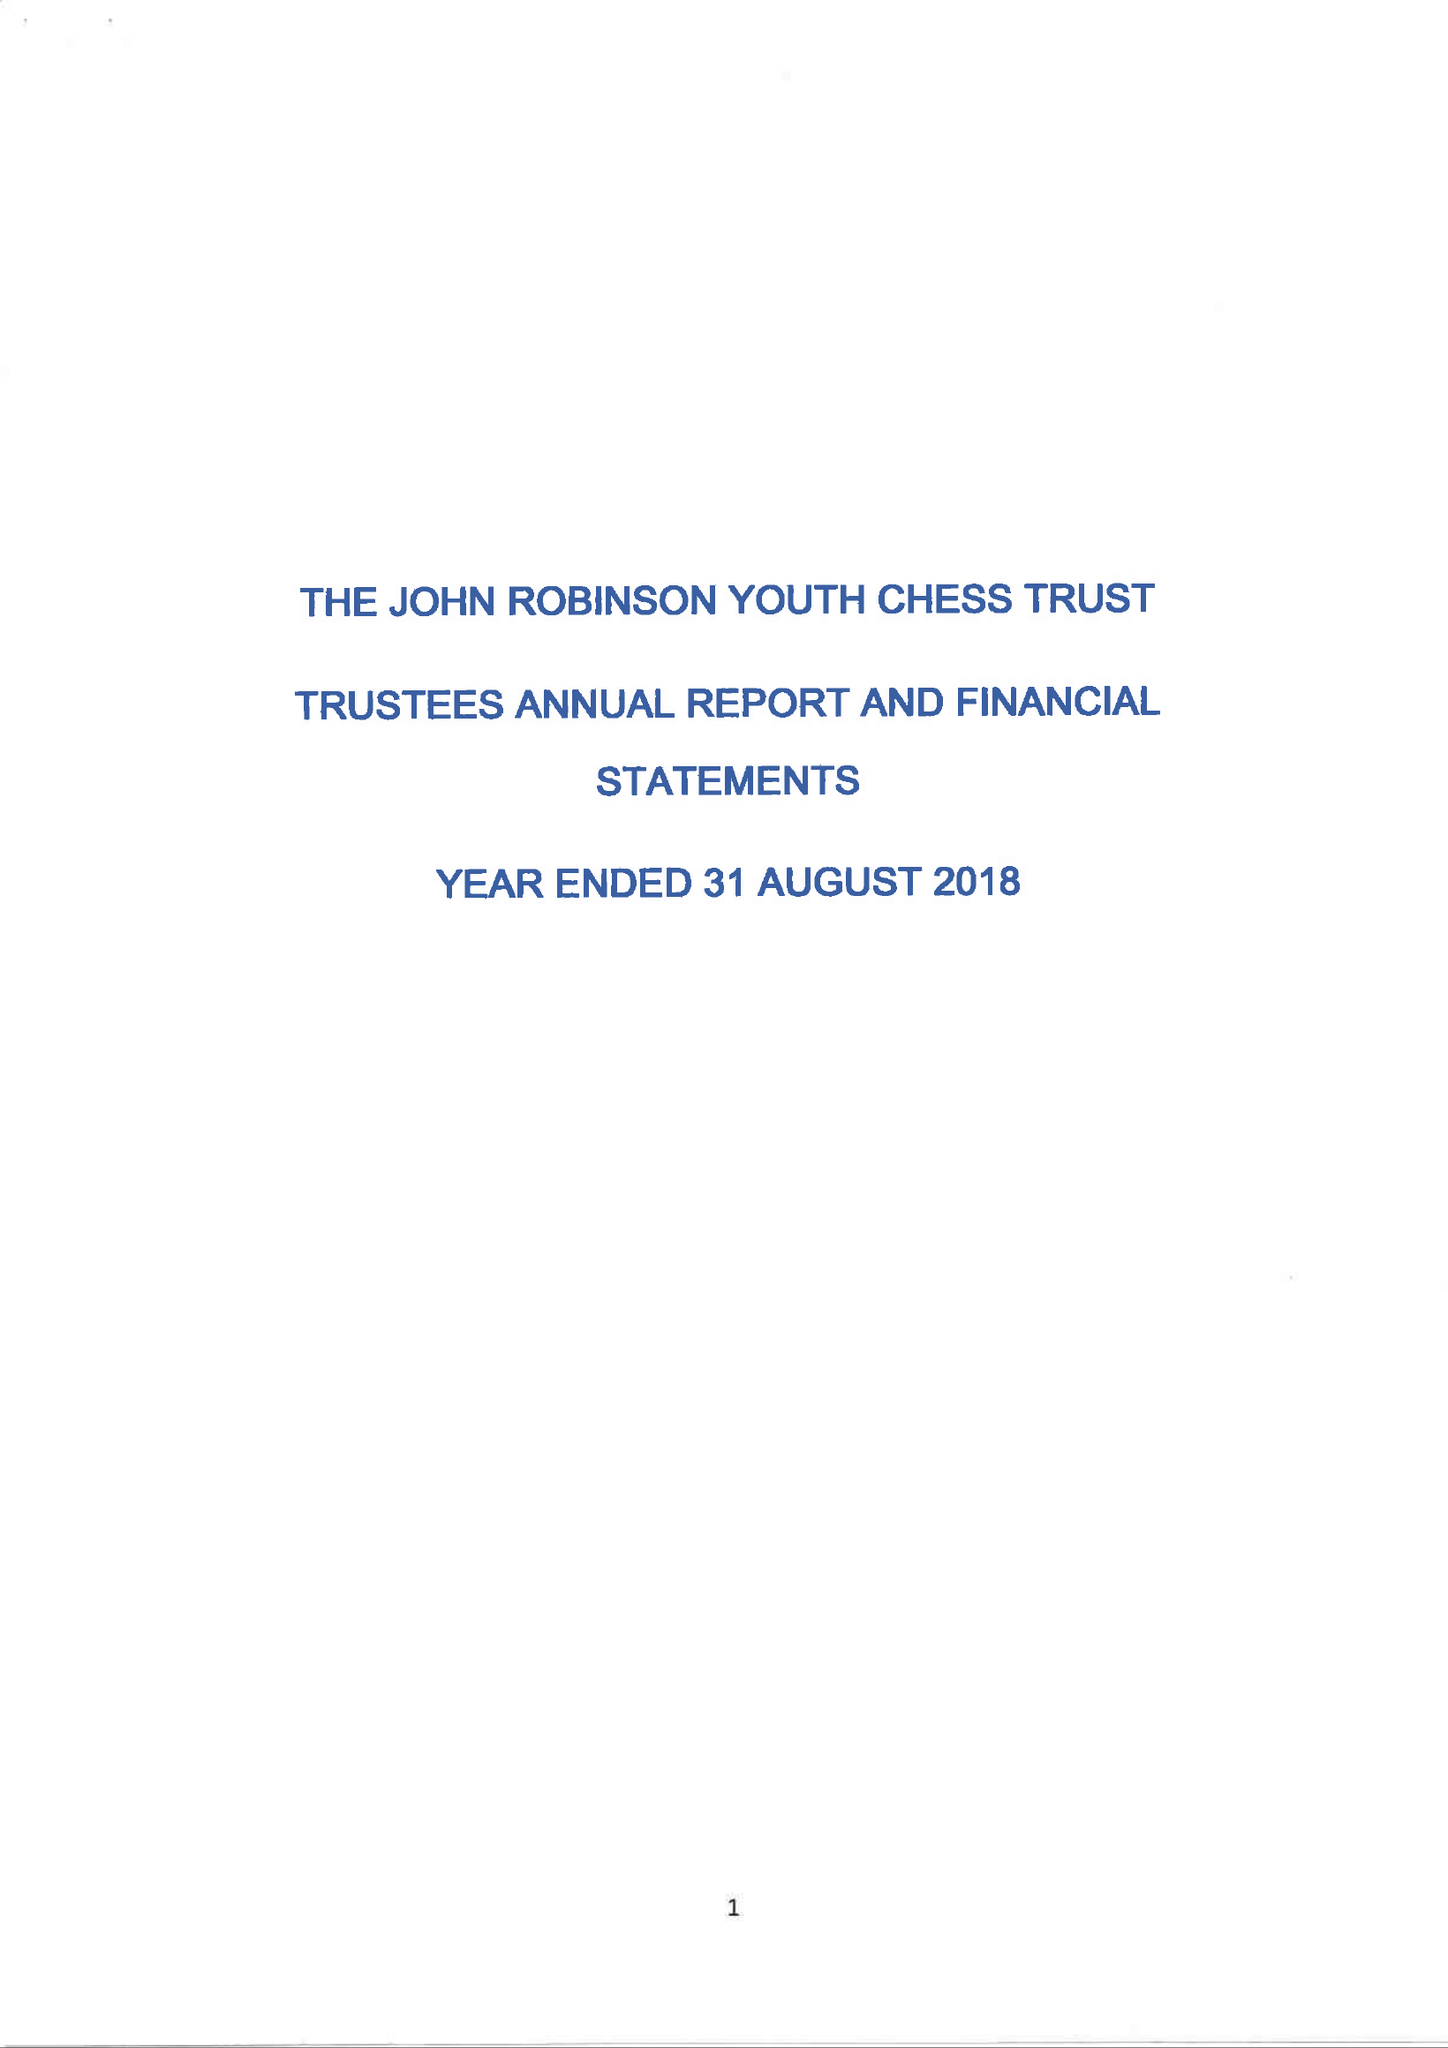What is the value for the charity_name?
Answer the question using a single word or phrase. The John Robinson Youth Chess Trust 